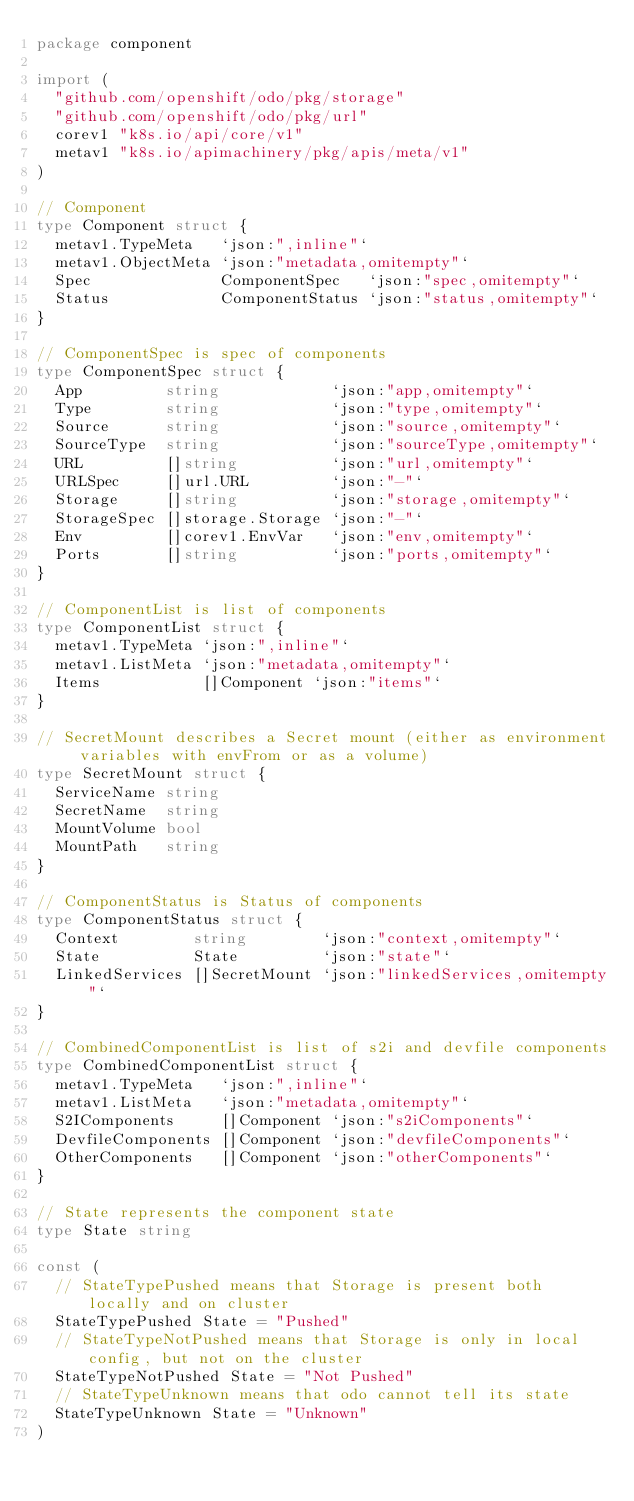Convert code to text. <code><loc_0><loc_0><loc_500><loc_500><_Go_>package component

import (
	"github.com/openshift/odo/pkg/storage"
	"github.com/openshift/odo/pkg/url"
	corev1 "k8s.io/api/core/v1"
	metav1 "k8s.io/apimachinery/pkg/apis/meta/v1"
)

// Component
type Component struct {
	metav1.TypeMeta   `json:",inline"`
	metav1.ObjectMeta `json:"metadata,omitempty"`
	Spec              ComponentSpec   `json:"spec,omitempty"`
	Status            ComponentStatus `json:"status,omitempty"`
}

// ComponentSpec is spec of components
type ComponentSpec struct {
	App         string            `json:"app,omitempty"`
	Type        string            `json:"type,omitempty"`
	Source      string            `json:"source,omitempty"`
	SourceType  string            `json:"sourceType,omitempty"`
	URL         []string          `json:"url,omitempty"`
	URLSpec     []url.URL         `json:"-"`
	Storage     []string          `json:"storage,omitempty"`
	StorageSpec []storage.Storage `json:"-"`
	Env         []corev1.EnvVar   `json:"env,omitempty"`
	Ports       []string          `json:"ports,omitempty"`
}

// ComponentList is list of components
type ComponentList struct {
	metav1.TypeMeta `json:",inline"`
	metav1.ListMeta `json:"metadata,omitempty"`
	Items           []Component `json:"items"`
}

// SecretMount describes a Secret mount (either as environment variables with envFrom or as a volume)
type SecretMount struct {
	ServiceName string
	SecretName  string
	MountVolume bool
	MountPath   string
}

// ComponentStatus is Status of components
type ComponentStatus struct {
	Context        string        `json:"context,omitempty"`
	State          State         `json:"state"`
	LinkedServices []SecretMount `json:"linkedServices,omitempty"`
}

// CombinedComponentList is list of s2i and devfile components
type CombinedComponentList struct {
	metav1.TypeMeta   `json:",inline"`
	metav1.ListMeta   `json:"metadata,omitempty"`
	S2IComponents     []Component `json:"s2iComponents"`
	DevfileComponents []Component `json:"devfileComponents"`
	OtherComponents   []Component `json:"otherComponents"`
}

// State represents the component state
type State string

const (
	// StateTypePushed means that Storage is present both locally and on cluster
	StateTypePushed State = "Pushed"
	// StateTypeNotPushed means that Storage is only in local config, but not on the cluster
	StateTypeNotPushed State = "Not Pushed"
	// StateTypeUnknown means that odo cannot tell its state
	StateTypeUnknown State = "Unknown"
)
</code> 